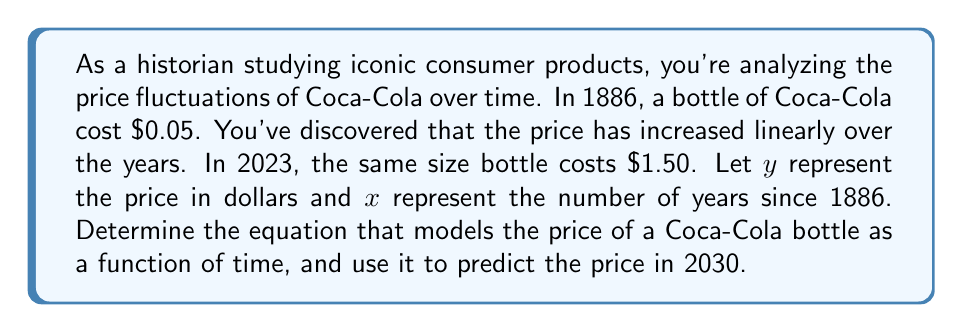Teach me how to tackle this problem. To solve this problem, we'll use a linear equation in the form $y = mx + b$, where:
$y$ = price in dollars
$x$ = number of years since 1886
$m$ = slope (price increase per year)
$b$ = y-intercept (initial price in 1886)

1. Determine the slope (m):
   Time difference: 2023 - 1886 = 137 years
   Price difference: $1.50 - $0.05 = $1.45
   Slope = $\frac{\text{change in y}}{\text{change in x}} = \frac{1.45}{137} \approx 0.0105839416$

2. Use the y-intercept (b):
   In 1886, x = 0 and y = $0.05, so b = 0.05

3. Form the equation:
   $y = 0.0105839416x + 0.05$

4. Predict the price in 2030:
   Years since 1886: 2030 - 1886 = 144
   $y = 0.0105839416(144) + 0.05$
   $y = 1.5240876704 + 0.05$
   $y = 1.5740876704$

Therefore, the predicted price in 2030 is approximately $1.57.
Answer: The equation modeling the price of a Coca-Cola bottle is $y = 0.0105839416x + 0.05$, where $y$ is the price in dollars and $x$ is the number of years since 1886. The predicted price in 2030 is approximately $1.57. 